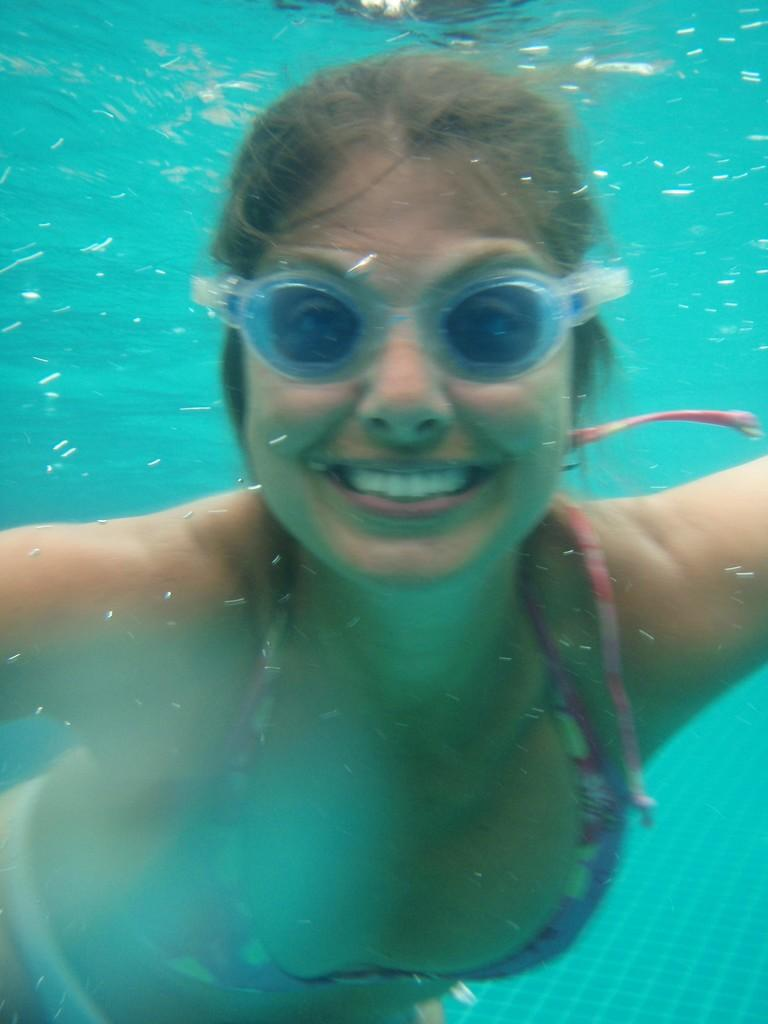Who is present in the image? There is a woman in the image. What is the woman doing in the image? The woman is in the water. What is the woman's facial expression in the image? The woman is smiling. What accessory is the woman wearing in the image? The woman is wearing swimming goggles. What type of club is the woman holding in the image? There is no club present in the image; the woman is wearing swimming goggles and is in the water. 